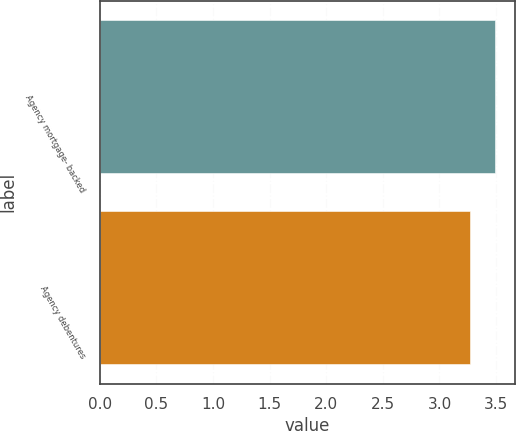<chart> <loc_0><loc_0><loc_500><loc_500><bar_chart><fcel>Agency mortgage- backed<fcel>Agency debentures<nl><fcel>3.49<fcel>3.27<nl></chart> 